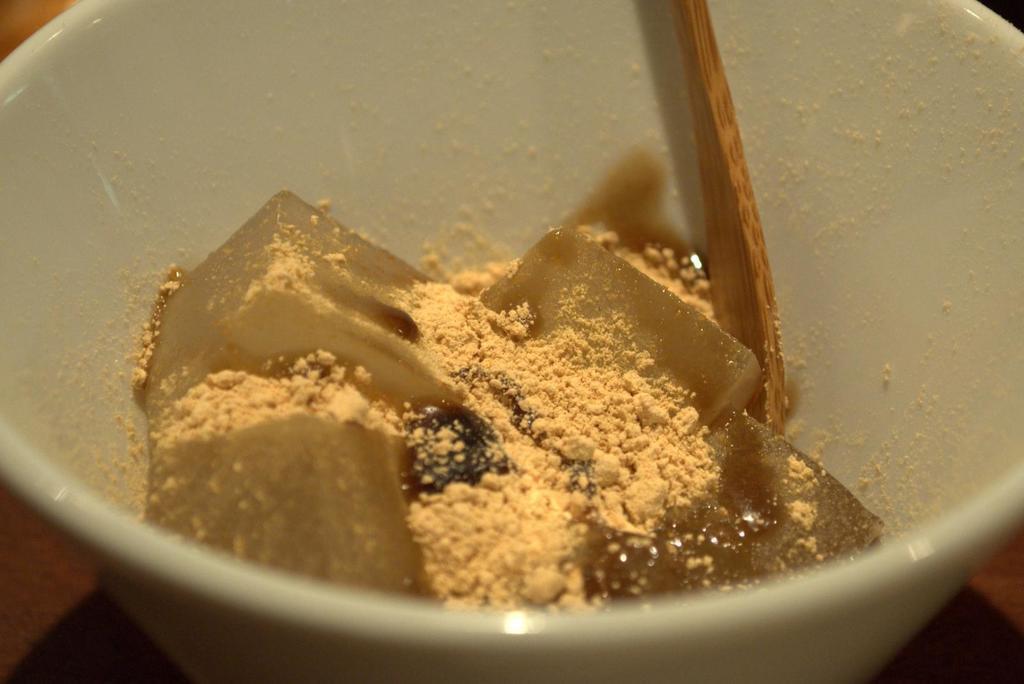Please provide a concise description of this image. In this image we can see a bowl containing food and a spoon placed on the surface. 